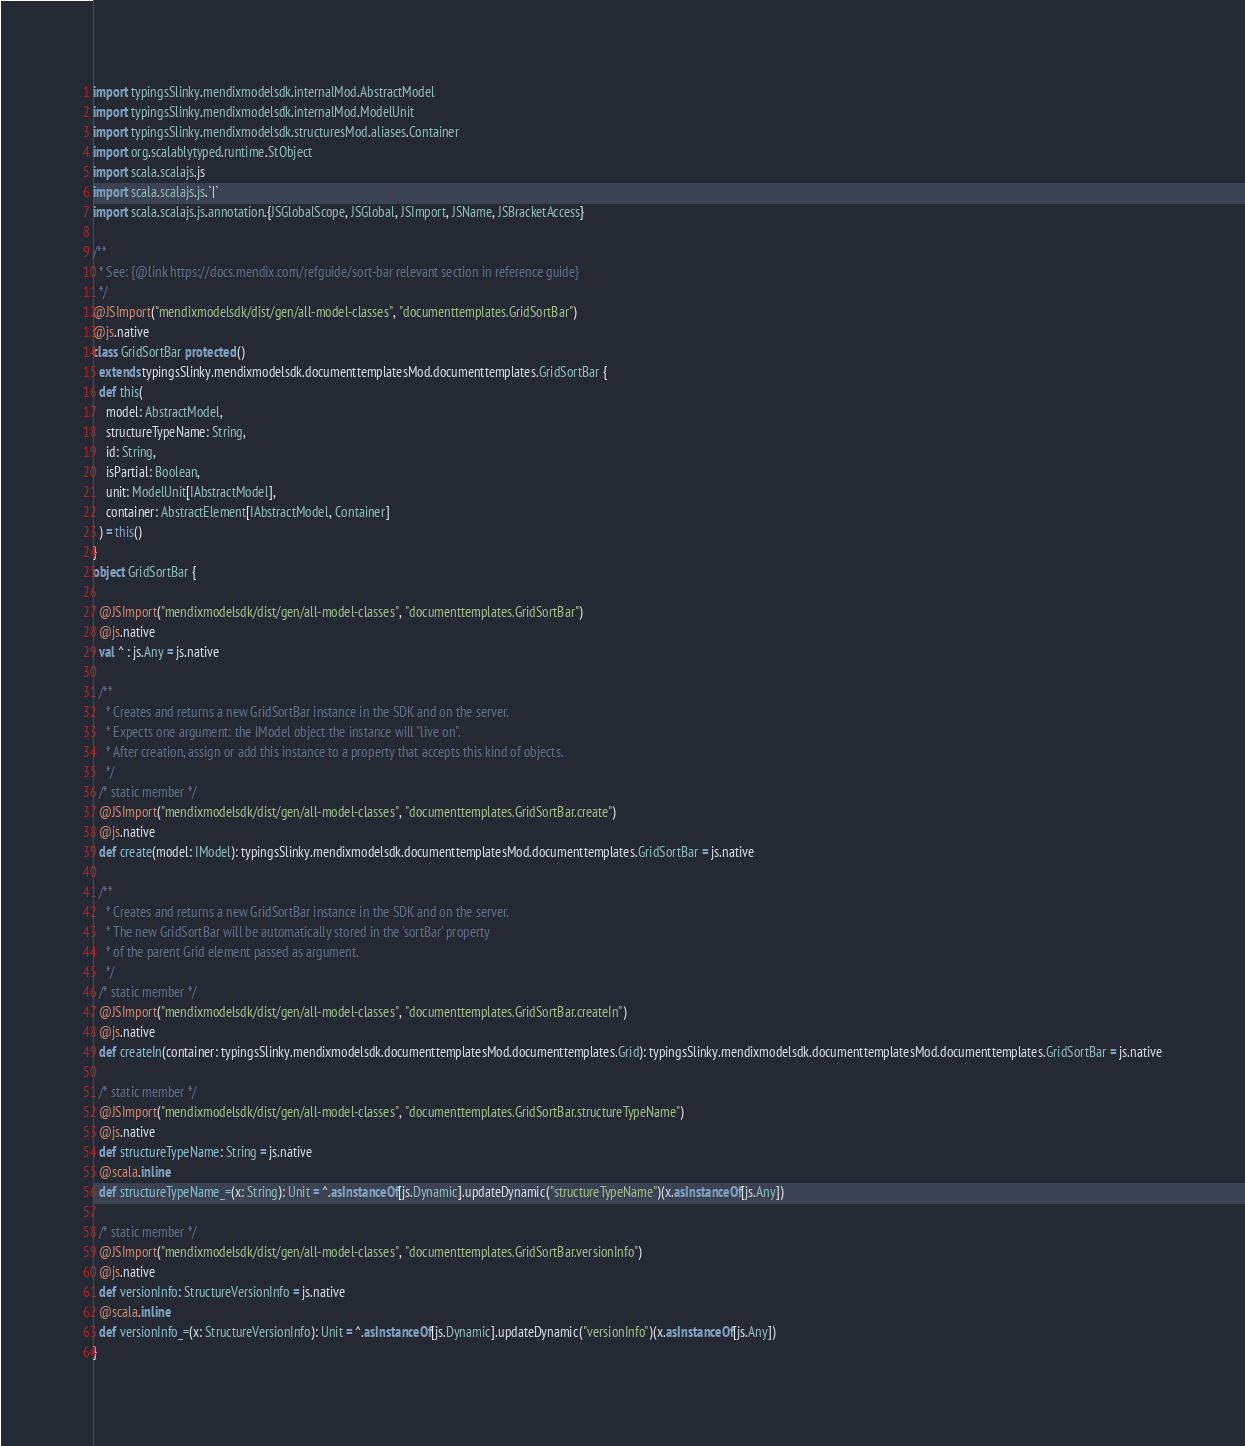<code> <loc_0><loc_0><loc_500><loc_500><_Scala_>import typingsSlinky.mendixmodelsdk.internalMod.AbstractModel
import typingsSlinky.mendixmodelsdk.internalMod.ModelUnit
import typingsSlinky.mendixmodelsdk.structuresMod.aliases.Container
import org.scalablytyped.runtime.StObject
import scala.scalajs.js
import scala.scalajs.js.`|`
import scala.scalajs.js.annotation.{JSGlobalScope, JSGlobal, JSImport, JSName, JSBracketAccess}

/**
  * See: {@link https://docs.mendix.com/refguide/sort-bar relevant section in reference guide}
  */
@JSImport("mendixmodelsdk/dist/gen/all-model-classes", "documenttemplates.GridSortBar")
@js.native
class GridSortBar protected ()
  extends typingsSlinky.mendixmodelsdk.documenttemplatesMod.documenttemplates.GridSortBar {
  def this(
    model: AbstractModel,
    structureTypeName: String,
    id: String,
    isPartial: Boolean,
    unit: ModelUnit[IAbstractModel],
    container: AbstractElement[IAbstractModel, Container]
  ) = this()
}
object GridSortBar {
  
  @JSImport("mendixmodelsdk/dist/gen/all-model-classes", "documenttemplates.GridSortBar")
  @js.native
  val ^ : js.Any = js.native
  
  /**
    * Creates and returns a new GridSortBar instance in the SDK and on the server.
    * Expects one argument: the IModel object the instance will "live on".
    * After creation, assign or add this instance to a property that accepts this kind of objects.
    */
  /* static member */
  @JSImport("mendixmodelsdk/dist/gen/all-model-classes", "documenttemplates.GridSortBar.create")
  @js.native
  def create(model: IModel): typingsSlinky.mendixmodelsdk.documenttemplatesMod.documenttemplates.GridSortBar = js.native
  
  /**
    * Creates and returns a new GridSortBar instance in the SDK and on the server.
    * The new GridSortBar will be automatically stored in the 'sortBar' property
    * of the parent Grid element passed as argument.
    */
  /* static member */
  @JSImport("mendixmodelsdk/dist/gen/all-model-classes", "documenttemplates.GridSortBar.createIn")
  @js.native
  def createIn(container: typingsSlinky.mendixmodelsdk.documenttemplatesMod.documenttemplates.Grid): typingsSlinky.mendixmodelsdk.documenttemplatesMod.documenttemplates.GridSortBar = js.native
  
  /* static member */
  @JSImport("mendixmodelsdk/dist/gen/all-model-classes", "documenttemplates.GridSortBar.structureTypeName")
  @js.native
  def structureTypeName: String = js.native
  @scala.inline
  def structureTypeName_=(x: String): Unit = ^.asInstanceOf[js.Dynamic].updateDynamic("structureTypeName")(x.asInstanceOf[js.Any])
  
  /* static member */
  @JSImport("mendixmodelsdk/dist/gen/all-model-classes", "documenttemplates.GridSortBar.versionInfo")
  @js.native
  def versionInfo: StructureVersionInfo = js.native
  @scala.inline
  def versionInfo_=(x: StructureVersionInfo): Unit = ^.asInstanceOf[js.Dynamic].updateDynamic("versionInfo")(x.asInstanceOf[js.Any])
}
</code> 